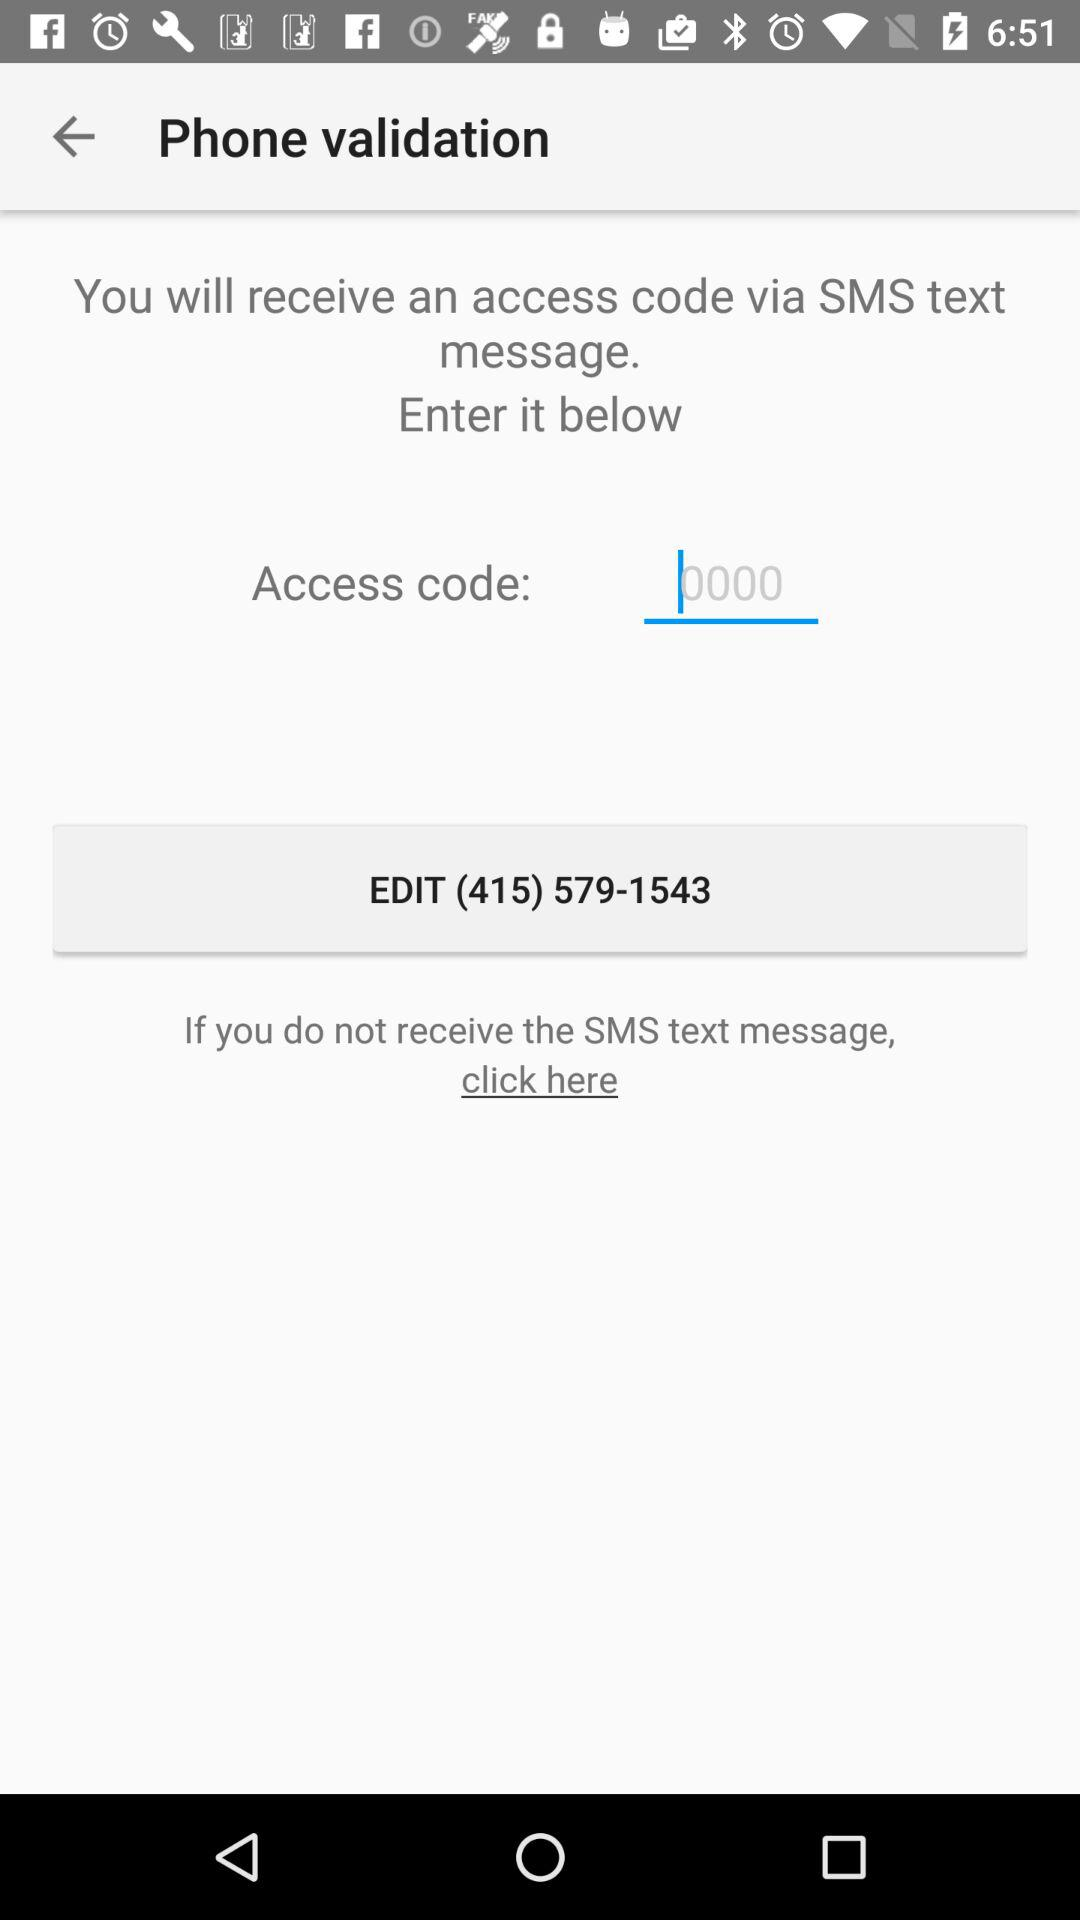What is the phone number for verification? The phone number is (415) 579-1543. 